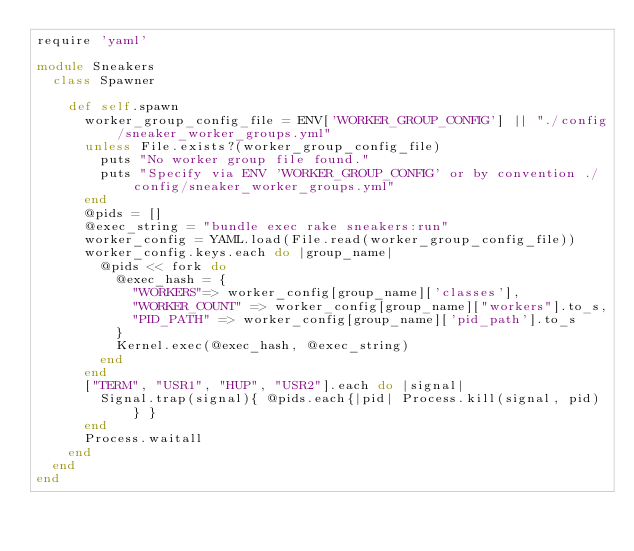<code> <loc_0><loc_0><loc_500><loc_500><_Ruby_>require 'yaml'

module Sneakers
  class Spawner

    def self.spawn
      worker_group_config_file = ENV['WORKER_GROUP_CONFIG'] || "./config/sneaker_worker_groups.yml"
      unless File.exists?(worker_group_config_file)
        puts "No worker group file found."
        puts "Specify via ENV 'WORKER_GROUP_CONFIG' or by convention ./config/sneaker_worker_groups.yml"
      end
      @pids = []
      @exec_string = "bundle exec rake sneakers:run"
      worker_config = YAML.load(File.read(worker_group_config_file))
      worker_config.keys.each do |group_name|
        @pids << fork do
          @exec_hash = {
            "WORKERS"=> worker_config[group_name]['classes'],
            "WORKER_COUNT" => worker_config[group_name]["workers"].to_s,
            "PID_PATH" => worker_config[group_name]['pid_path'].to_s
          }
          Kernel.exec(@exec_hash, @exec_string)
        end
      end
      ["TERM", "USR1", "HUP", "USR2"].each do |signal|
        Signal.trap(signal){ @pids.each{|pid| Process.kill(signal, pid) } }
      end
      Process.waitall
    end
  end
end
</code> 